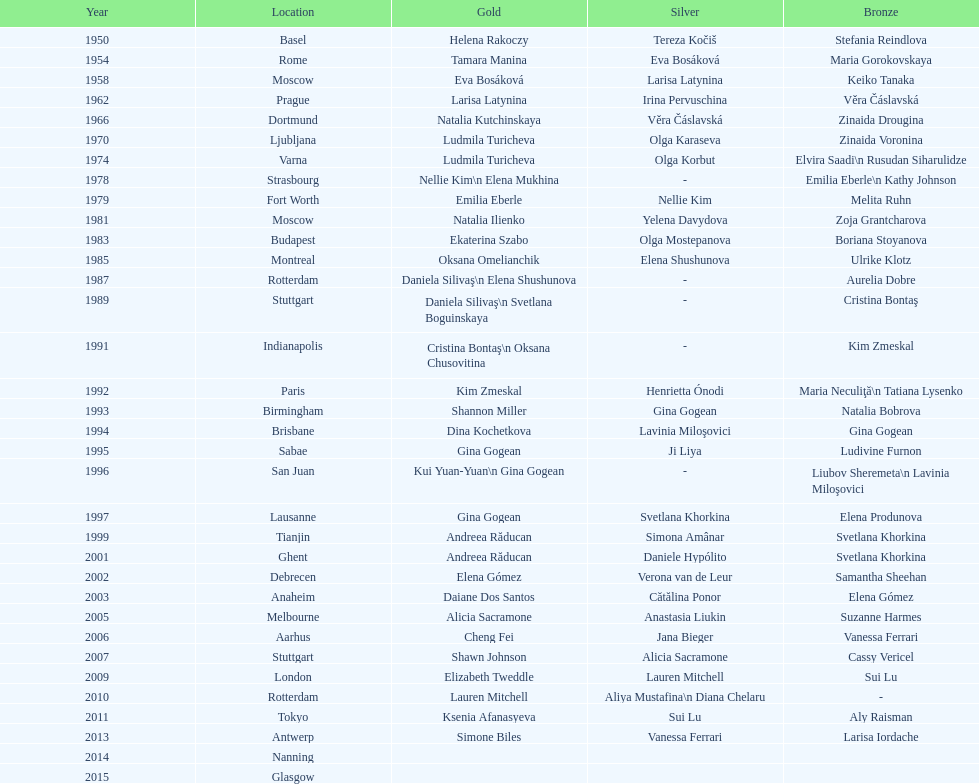How many instances was the location in the united states? 3. 